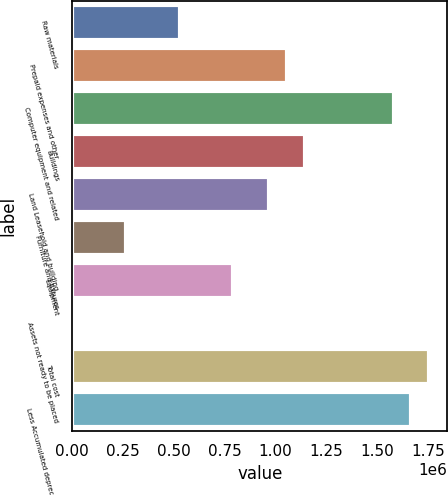Convert chart. <chart><loc_0><loc_0><loc_500><loc_500><bar_chart><fcel>Raw materials<fcel>Prepaid expenses and other<fcel>Computer equipment and related<fcel>Buildings<fcel>Land Leasehold and building<fcel>Furniture and fixtures<fcel>Equipment<fcel>Assets not ready to be placed<fcel>Total cost<fcel>Less Accumulated depreciation<nl><fcel>528721<fcel>1.05547e+06<fcel>1.58222e+06<fcel>1.14326e+06<fcel>967681<fcel>265345<fcel>792097<fcel>1969<fcel>1.75781e+06<fcel>1.67002e+06<nl></chart> 